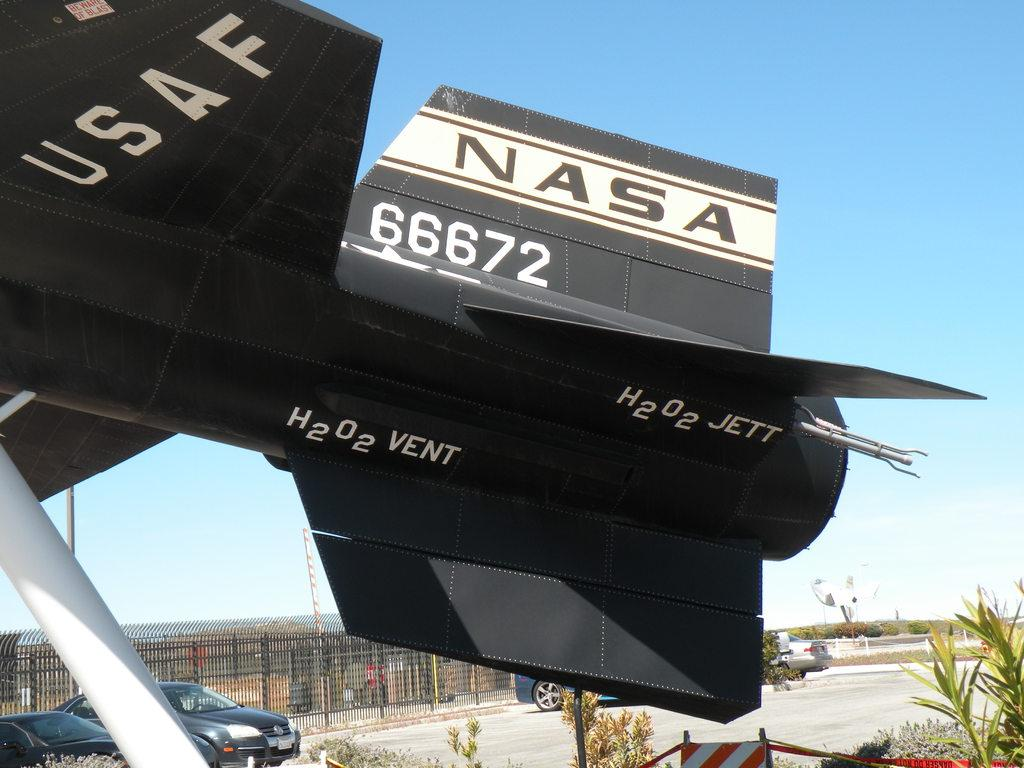<image>
Share a concise interpretation of the image provided. the tail of a NASA airplane number 66672 